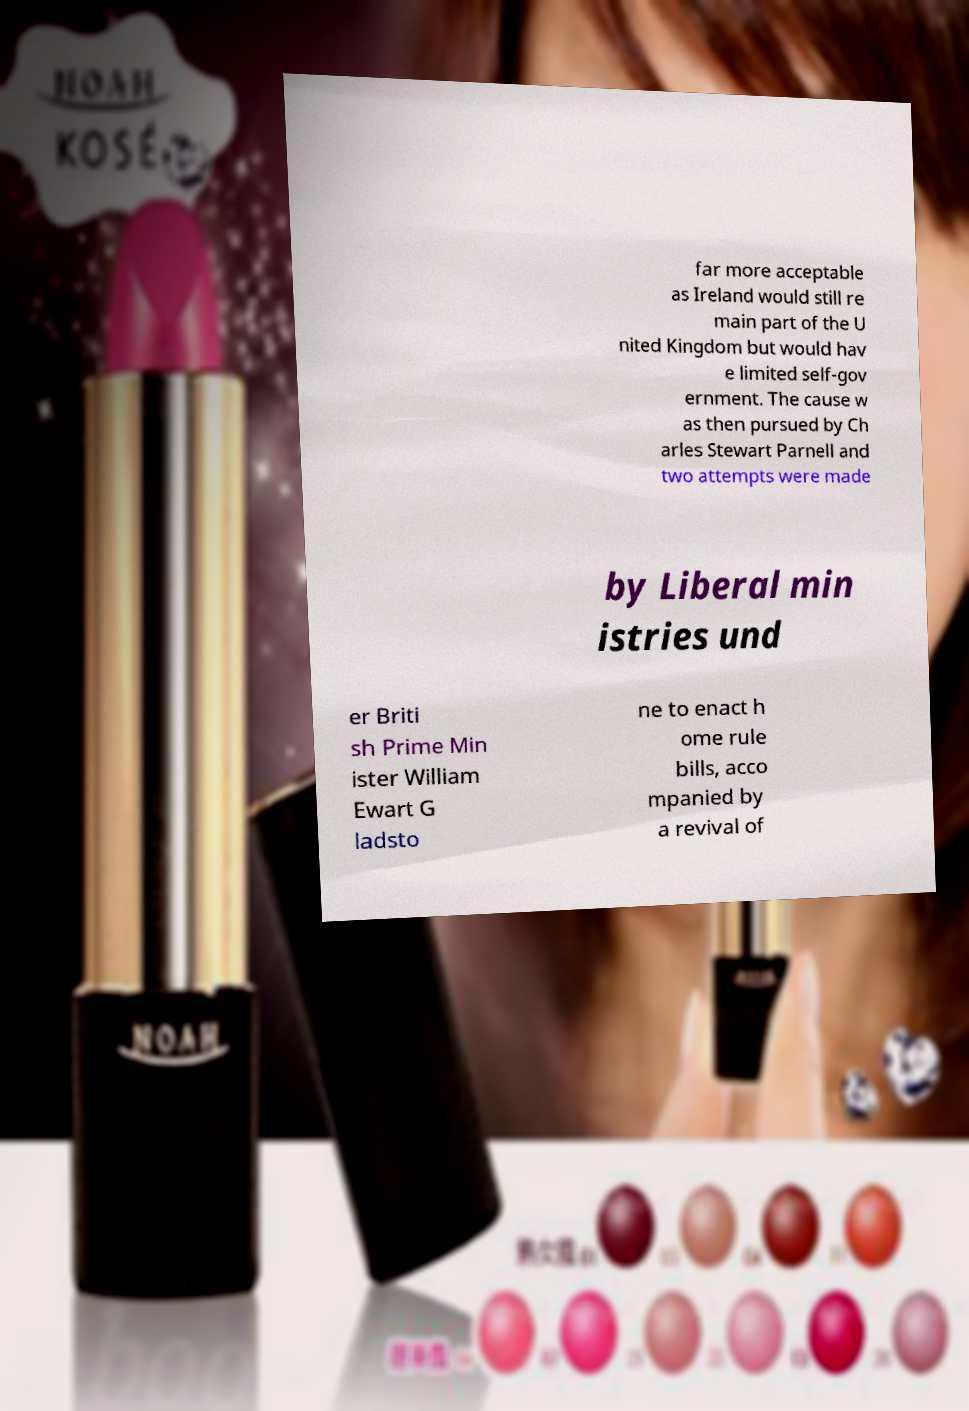I need the written content from this picture converted into text. Can you do that? far more acceptable as Ireland would still re main part of the U nited Kingdom but would hav e limited self-gov ernment. The cause w as then pursued by Ch arles Stewart Parnell and two attempts were made by Liberal min istries und er Briti sh Prime Min ister William Ewart G ladsto ne to enact h ome rule bills, acco mpanied by a revival of 